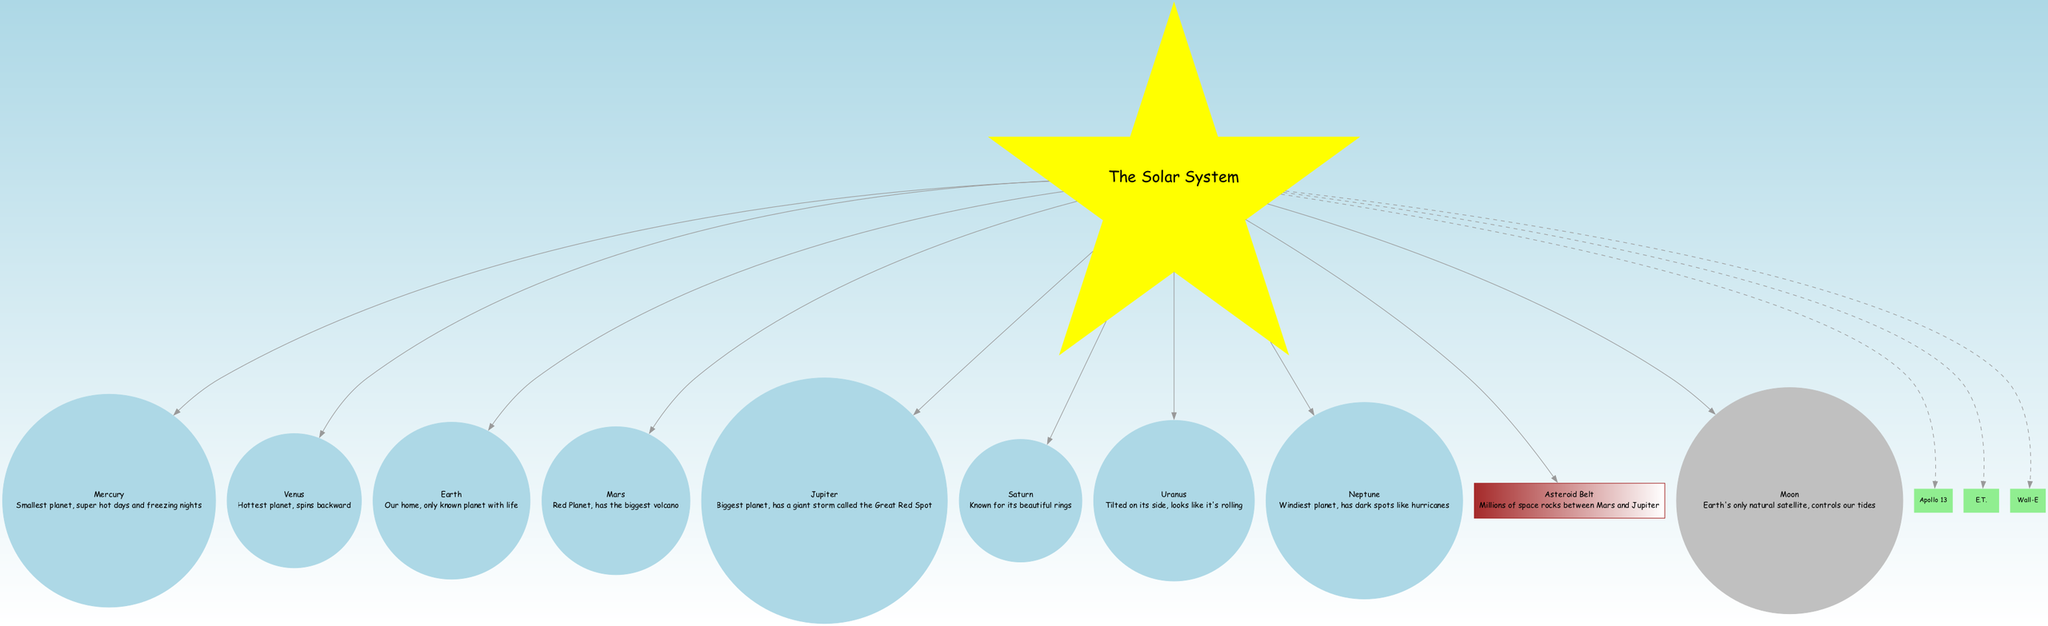What is the smallest planet? The diagram lists Mercury as the smallest planet alongside its fun fact. Therefore, by referencing the node that represents the planets, I can identify that Mercury is mentioned.
Answer: Mercury Which planet is known for its rings? According to the diagram, Saturn is highlighted as the planet known for its beautiful rings. By looking specifically at each planet, I see that Saturn's node contains this fun fact.
Answer: Saturn How many planets are in the solar system? In the diagram, there are eight planets listed under the "Solar System" node. By counting the number of planet nodes, I arrive at the total.
Answer: 8 What celestial body is between Mars and Jupiter? The diagram specifies the Asteroid Belt as the body located between Mars and Jupiter. This information can be directly obtained from the "other bodies" section of the diagram.
Answer: Asteroid Belt Which planet has the biggest volcano? From the diagram, Mars is indicated as the planet with the biggest volcano alongside its fun fact. Thus, I look for the Mars node, which provides this specific information.
Answer: Mars What type of celestial body is the Moon? The diagram categorizes the Moon as Earth's only natural satellite. By observing the type of node the Moon is associated with, I understand its classification as a satellite clearly.
Answer: Natural satellite Which planet spins backward? According to the information presented, Venus is noted for spinning backward, which I can verify by finding the Venus node in the diagram.
Answer: Venus What is the windiest planet? The diagram shows Neptune as the windiest planet, with a fun fact indicating its stormy nature. By finding the Neptune node, I confirm this point.
Answer: Neptune What movie is about space exploration? Among the movies listed in the diagram, Apollo 13 is specifically related to space exploration. By inspecting the movie nodes, Apollo 13 is recognized for this theme.
Answer: Apollo 13 